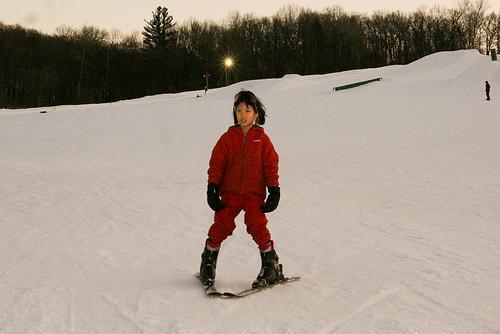What is the child standing on?
Make your selection from the four choices given to correctly answer the question.
Options: Grass, box, snow, sand. Snow. 